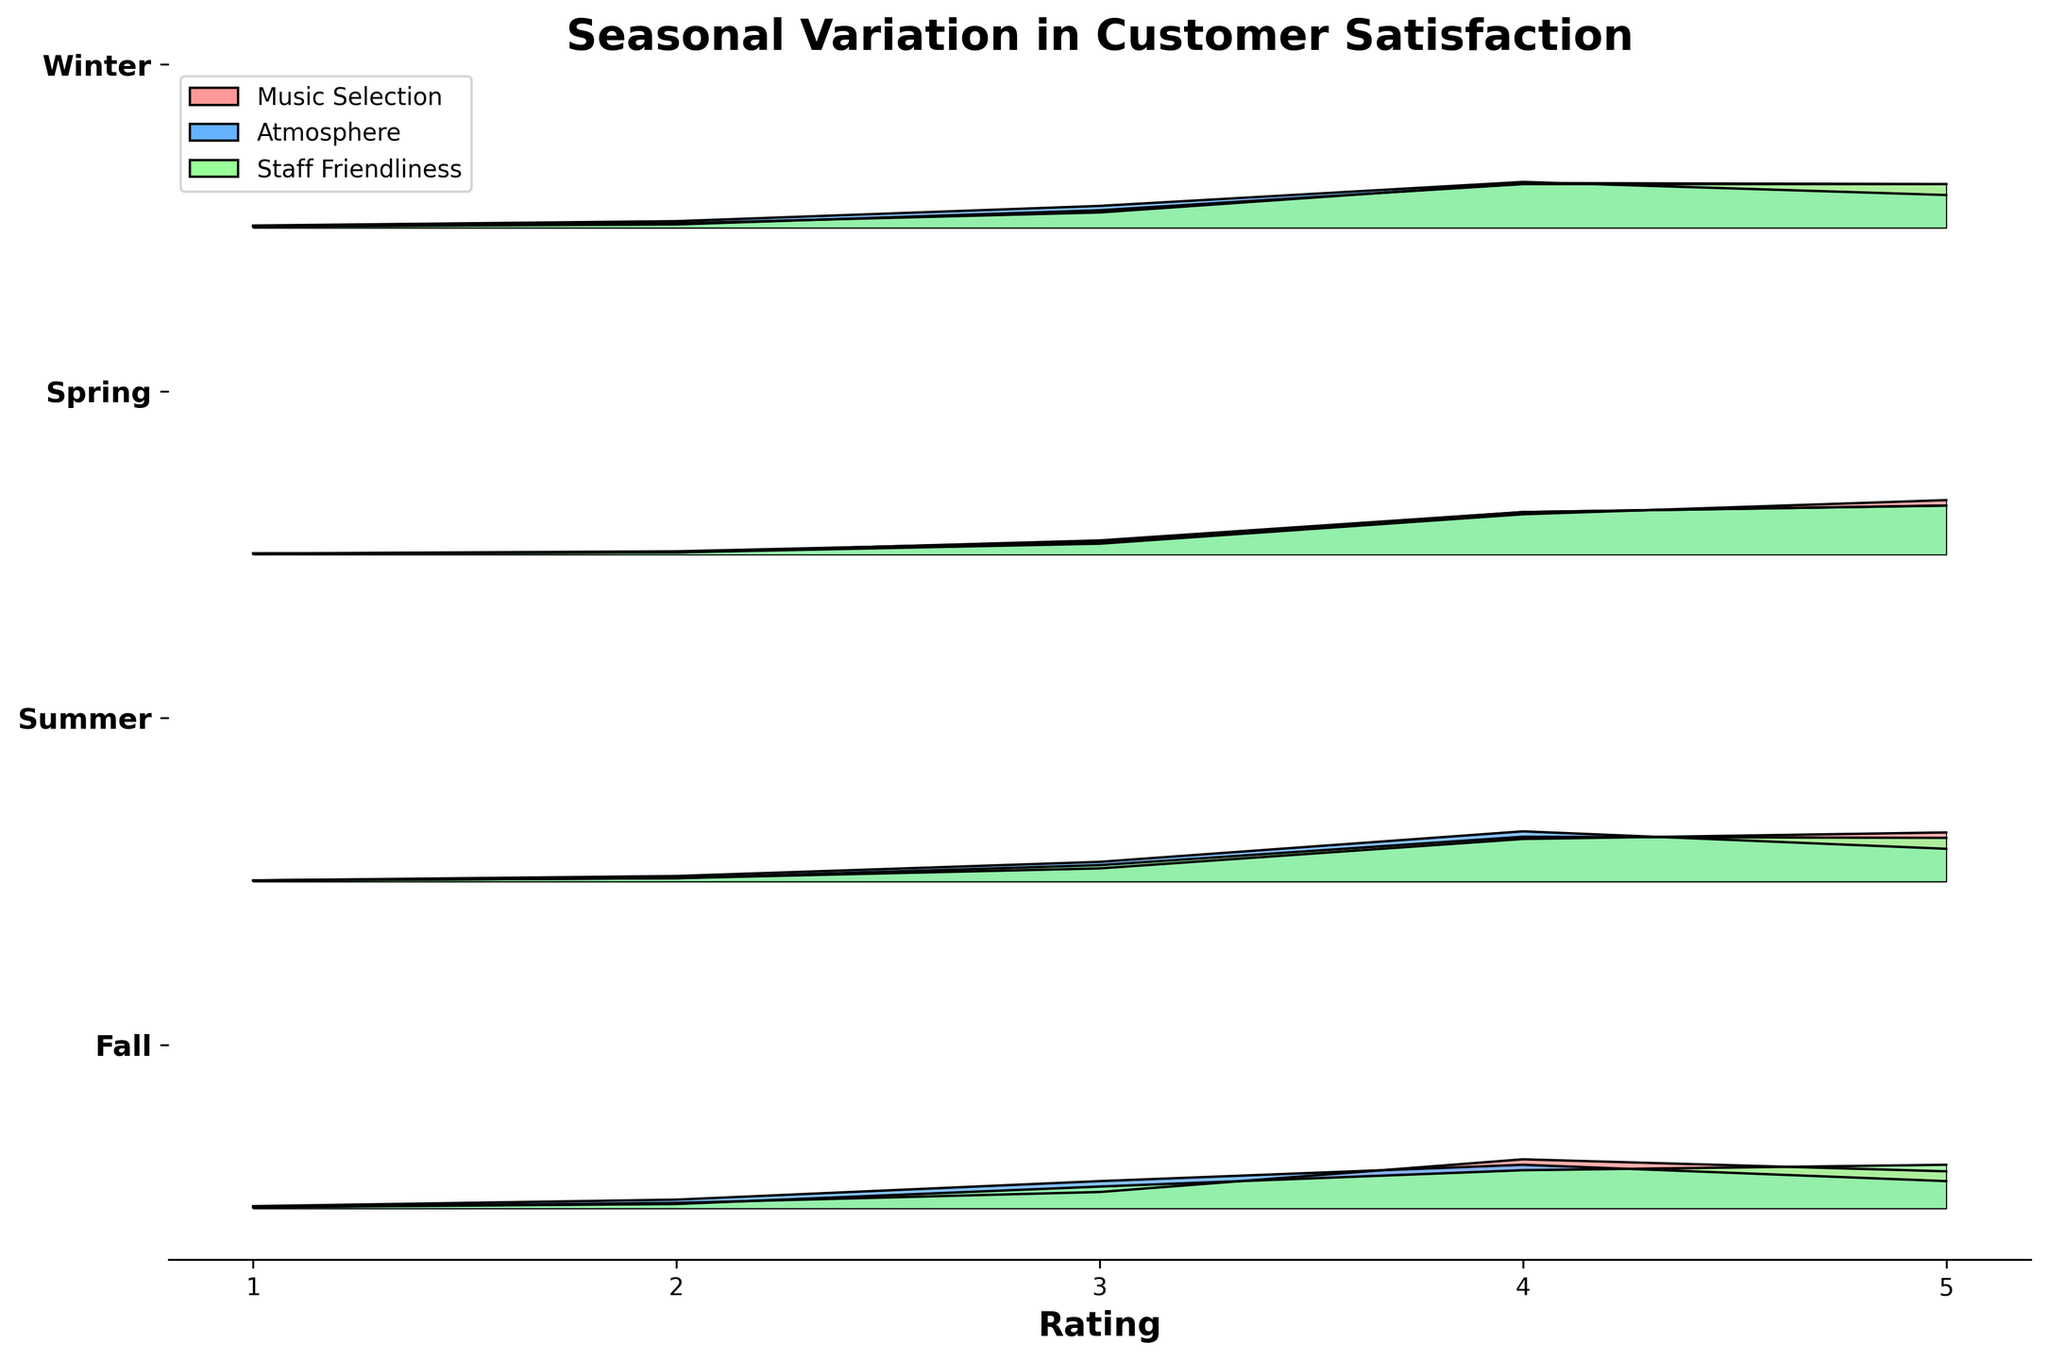Which season has the highest customer satisfaction rating for Music Selection? Look at the ridgeline plot for Music Selection across all seasons. Identify the season where the density curve is highest for the rating 5.
Answer: Summer What rating is most frequently given for Staff Friendliness in Winter? Observe the density curve for Staff Friendliness during Winter and see which rating has the highest density value.
Answer: 5 Which aspect has the most consistent high ratings across all seasons? Compare the density curves for each aspect across all seasons. The aspect with consistently high peaks at rating 5 across seasons has the most consistent high ratings.
Answer: Staff Friendliness In Fall, which aspect has the lowest customer satisfaction rating on average? Check the density curves for Fall and see which aspect has higher density values at the lower ratings (1, 2, and 3).
Answer: Atmosphere How does the average customer satisfaction rating for Atmosphere in Spring compare to that in Fall? Compare the density curves for Atmosphere in both Spring and Fall, focusing on where higher density values lie relative to the rating axis.
Answer: Higher in Spring Is there a season where the customer satisfaction ratings for Music Selection are lower on average? Look at the density curves for Music Selection across seasons to find any season where ratings tend to have higher densities at lower values (1, 2, 3).
Answer: Winter What is the title of the plot? Read the title provided at the top of the plot.
Answer: Seasonal Variation in Customer Satisfaction Which axis represents the customer rating scales? Look at the labels on the axes; the axis with numbers ranging from 1 to 5 represents the ratings.
Answer: X axis In Summer, which aspect has the highest peak in the density curve? Examine the density curves for Summer and look for the aspect with the highest peak.
Answer: Music Selection Which aspect has the least variation in customer satisfaction ratings in any season? Look for the aspect with the narrowest spread (densest curves) in any season, indicating less variation.
Answer: Staff Friendliness 